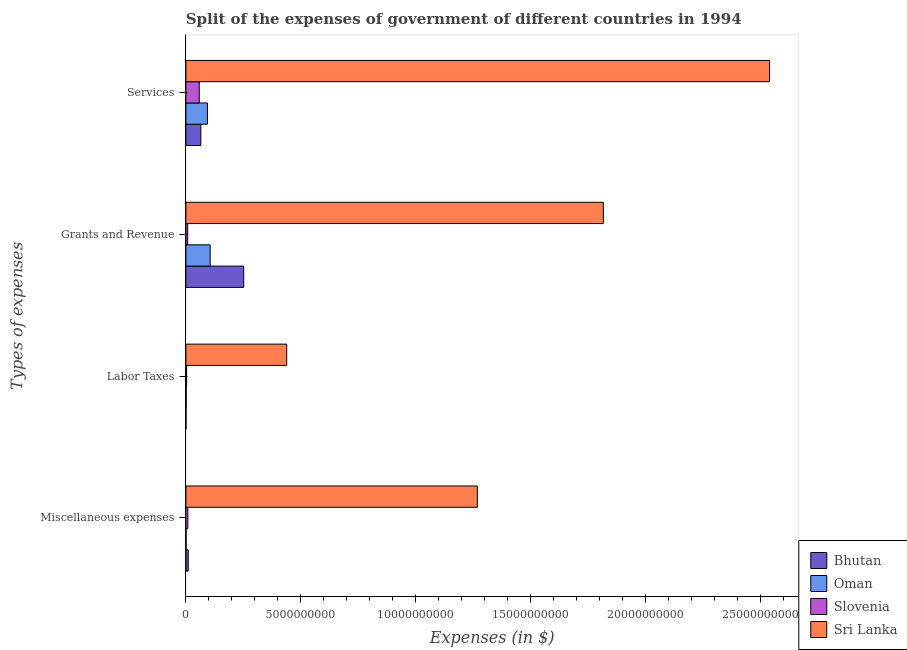How many different coloured bars are there?
Give a very brief answer. 4. Are the number of bars on each tick of the Y-axis equal?
Offer a very short reply. Yes. How many bars are there on the 4th tick from the top?
Make the answer very short. 4. How many bars are there on the 1st tick from the bottom?
Your answer should be compact. 4. What is the label of the 1st group of bars from the top?
Ensure brevity in your answer.  Services. What is the amount spent on services in Slovenia?
Your answer should be compact. 5.81e+08. Across all countries, what is the maximum amount spent on services?
Your answer should be compact. 2.54e+1. Across all countries, what is the minimum amount spent on labor taxes?
Offer a terse response. 6.70e+06. In which country was the amount spent on miscellaneous expenses maximum?
Your response must be concise. Sri Lanka. In which country was the amount spent on services minimum?
Ensure brevity in your answer.  Slovenia. What is the total amount spent on labor taxes in the graph?
Your answer should be very brief. 4.44e+09. What is the difference between the amount spent on grants and revenue in Sri Lanka and that in Slovenia?
Ensure brevity in your answer.  1.81e+1. What is the difference between the amount spent on miscellaneous expenses in Oman and the amount spent on grants and revenue in Slovenia?
Keep it short and to the point. -6.95e+07. What is the average amount spent on grants and revenue per country?
Ensure brevity in your answer.  5.45e+09. What is the difference between the amount spent on grants and revenue and amount spent on labor taxes in Bhutan?
Your answer should be very brief. 2.51e+09. In how many countries, is the amount spent on grants and revenue greater than 1000000000 $?
Offer a very short reply. 3. What is the ratio of the amount spent on miscellaneous expenses in Sri Lanka to that in Oman?
Make the answer very short. 1491.65. What is the difference between the highest and the second highest amount spent on miscellaneous expenses?
Ensure brevity in your answer.  1.26e+1. What is the difference between the highest and the lowest amount spent on services?
Your answer should be very brief. 2.48e+1. In how many countries, is the amount spent on miscellaneous expenses greater than the average amount spent on miscellaneous expenses taken over all countries?
Offer a very short reply. 1. Is the sum of the amount spent on services in Slovenia and Bhutan greater than the maximum amount spent on labor taxes across all countries?
Give a very brief answer. No. Is it the case that in every country, the sum of the amount spent on labor taxes and amount spent on miscellaneous expenses is greater than the sum of amount spent on services and amount spent on grants and revenue?
Keep it short and to the point. No. What does the 2nd bar from the top in Grants and Revenue represents?
Provide a short and direct response. Slovenia. What does the 2nd bar from the bottom in Grants and Revenue represents?
Ensure brevity in your answer.  Oman. What is the difference between two consecutive major ticks on the X-axis?
Your answer should be very brief. 5.00e+09. Does the graph contain grids?
Give a very brief answer. No. What is the title of the graph?
Provide a succinct answer. Split of the expenses of government of different countries in 1994. Does "Lao PDR" appear as one of the legend labels in the graph?
Make the answer very short. No. What is the label or title of the X-axis?
Provide a short and direct response. Expenses (in $). What is the label or title of the Y-axis?
Give a very brief answer. Types of expenses. What is the Expenses (in $) in Bhutan in Miscellaneous expenses?
Give a very brief answer. 1.03e+08. What is the Expenses (in $) of Oman in Miscellaneous expenses?
Give a very brief answer. 8.50e+06. What is the Expenses (in $) of Slovenia in Miscellaneous expenses?
Give a very brief answer. 8.64e+07. What is the Expenses (in $) of Sri Lanka in Miscellaneous expenses?
Offer a very short reply. 1.27e+1. What is the Expenses (in $) in Bhutan in Labor Taxes?
Keep it short and to the point. 6.70e+06. What is the Expenses (in $) in Oman in Labor Taxes?
Offer a terse response. 1.62e+07. What is the Expenses (in $) of Slovenia in Labor Taxes?
Keep it short and to the point. 3.09e+07. What is the Expenses (in $) in Sri Lanka in Labor Taxes?
Make the answer very short. 4.39e+09. What is the Expenses (in $) in Bhutan in Grants and Revenue?
Provide a succinct answer. 2.52e+09. What is the Expenses (in $) of Oman in Grants and Revenue?
Provide a short and direct response. 1.06e+09. What is the Expenses (in $) of Slovenia in Grants and Revenue?
Offer a very short reply. 7.80e+07. What is the Expenses (in $) of Sri Lanka in Grants and Revenue?
Keep it short and to the point. 1.82e+1. What is the Expenses (in $) of Bhutan in Services?
Provide a succinct answer. 6.51e+08. What is the Expenses (in $) of Oman in Services?
Your answer should be very brief. 9.37e+08. What is the Expenses (in $) in Slovenia in Services?
Make the answer very short. 5.81e+08. What is the Expenses (in $) of Sri Lanka in Services?
Offer a terse response. 2.54e+1. Across all Types of expenses, what is the maximum Expenses (in $) in Bhutan?
Keep it short and to the point. 2.52e+09. Across all Types of expenses, what is the maximum Expenses (in $) of Oman?
Keep it short and to the point. 1.06e+09. Across all Types of expenses, what is the maximum Expenses (in $) of Slovenia?
Offer a terse response. 5.81e+08. Across all Types of expenses, what is the maximum Expenses (in $) in Sri Lanka?
Offer a very short reply. 2.54e+1. Across all Types of expenses, what is the minimum Expenses (in $) in Bhutan?
Your response must be concise. 6.70e+06. Across all Types of expenses, what is the minimum Expenses (in $) in Oman?
Keep it short and to the point. 8.50e+06. Across all Types of expenses, what is the minimum Expenses (in $) in Slovenia?
Provide a succinct answer. 3.09e+07. Across all Types of expenses, what is the minimum Expenses (in $) of Sri Lanka?
Ensure brevity in your answer.  4.39e+09. What is the total Expenses (in $) of Bhutan in the graph?
Provide a succinct answer. 3.28e+09. What is the total Expenses (in $) in Oman in the graph?
Provide a short and direct response. 2.02e+09. What is the total Expenses (in $) in Slovenia in the graph?
Make the answer very short. 7.76e+08. What is the total Expenses (in $) of Sri Lanka in the graph?
Give a very brief answer. 6.06e+1. What is the difference between the Expenses (in $) in Bhutan in Miscellaneous expenses and that in Labor Taxes?
Make the answer very short. 9.59e+07. What is the difference between the Expenses (in $) in Oman in Miscellaneous expenses and that in Labor Taxes?
Provide a succinct answer. -7.70e+06. What is the difference between the Expenses (in $) of Slovenia in Miscellaneous expenses and that in Labor Taxes?
Provide a succinct answer. 5.55e+07. What is the difference between the Expenses (in $) in Sri Lanka in Miscellaneous expenses and that in Labor Taxes?
Your answer should be very brief. 8.29e+09. What is the difference between the Expenses (in $) of Bhutan in Miscellaneous expenses and that in Grants and Revenue?
Make the answer very short. -2.41e+09. What is the difference between the Expenses (in $) in Oman in Miscellaneous expenses and that in Grants and Revenue?
Give a very brief answer. -1.05e+09. What is the difference between the Expenses (in $) of Slovenia in Miscellaneous expenses and that in Grants and Revenue?
Make the answer very short. 8.35e+06. What is the difference between the Expenses (in $) in Sri Lanka in Miscellaneous expenses and that in Grants and Revenue?
Offer a very short reply. -5.48e+09. What is the difference between the Expenses (in $) of Bhutan in Miscellaneous expenses and that in Services?
Ensure brevity in your answer.  -5.48e+08. What is the difference between the Expenses (in $) of Oman in Miscellaneous expenses and that in Services?
Ensure brevity in your answer.  -9.29e+08. What is the difference between the Expenses (in $) in Slovenia in Miscellaneous expenses and that in Services?
Your answer should be very brief. -4.94e+08. What is the difference between the Expenses (in $) in Sri Lanka in Miscellaneous expenses and that in Services?
Ensure brevity in your answer.  -1.27e+1. What is the difference between the Expenses (in $) of Bhutan in Labor Taxes and that in Grants and Revenue?
Offer a very short reply. -2.51e+09. What is the difference between the Expenses (in $) in Oman in Labor Taxes and that in Grants and Revenue?
Your answer should be compact. -1.04e+09. What is the difference between the Expenses (in $) of Slovenia in Labor Taxes and that in Grants and Revenue?
Your answer should be compact. -4.72e+07. What is the difference between the Expenses (in $) in Sri Lanka in Labor Taxes and that in Grants and Revenue?
Offer a very short reply. -1.38e+1. What is the difference between the Expenses (in $) in Bhutan in Labor Taxes and that in Services?
Provide a short and direct response. -6.44e+08. What is the difference between the Expenses (in $) of Oman in Labor Taxes and that in Services?
Your response must be concise. -9.21e+08. What is the difference between the Expenses (in $) of Slovenia in Labor Taxes and that in Services?
Give a very brief answer. -5.50e+08. What is the difference between the Expenses (in $) in Sri Lanka in Labor Taxes and that in Services?
Give a very brief answer. -2.10e+1. What is the difference between the Expenses (in $) in Bhutan in Grants and Revenue and that in Services?
Provide a short and direct response. 1.86e+09. What is the difference between the Expenses (in $) of Oman in Grants and Revenue and that in Services?
Make the answer very short. 1.19e+08. What is the difference between the Expenses (in $) of Slovenia in Grants and Revenue and that in Services?
Provide a short and direct response. -5.03e+08. What is the difference between the Expenses (in $) of Sri Lanka in Grants and Revenue and that in Services?
Your answer should be very brief. -7.23e+09. What is the difference between the Expenses (in $) in Bhutan in Miscellaneous expenses and the Expenses (in $) in Oman in Labor Taxes?
Your answer should be very brief. 8.64e+07. What is the difference between the Expenses (in $) in Bhutan in Miscellaneous expenses and the Expenses (in $) in Slovenia in Labor Taxes?
Your answer should be very brief. 7.17e+07. What is the difference between the Expenses (in $) of Bhutan in Miscellaneous expenses and the Expenses (in $) of Sri Lanka in Labor Taxes?
Your answer should be very brief. -4.28e+09. What is the difference between the Expenses (in $) of Oman in Miscellaneous expenses and the Expenses (in $) of Slovenia in Labor Taxes?
Your answer should be very brief. -2.24e+07. What is the difference between the Expenses (in $) in Oman in Miscellaneous expenses and the Expenses (in $) in Sri Lanka in Labor Taxes?
Offer a terse response. -4.38e+09. What is the difference between the Expenses (in $) in Slovenia in Miscellaneous expenses and the Expenses (in $) in Sri Lanka in Labor Taxes?
Give a very brief answer. -4.30e+09. What is the difference between the Expenses (in $) in Bhutan in Miscellaneous expenses and the Expenses (in $) in Oman in Grants and Revenue?
Keep it short and to the point. -9.54e+08. What is the difference between the Expenses (in $) of Bhutan in Miscellaneous expenses and the Expenses (in $) of Slovenia in Grants and Revenue?
Ensure brevity in your answer.  2.46e+07. What is the difference between the Expenses (in $) in Bhutan in Miscellaneous expenses and the Expenses (in $) in Sri Lanka in Grants and Revenue?
Offer a very short reply. -1.81e+1. What is the difference between the Expenses (in $) in Oman in Miscellaneous expenses and the Expenses (in $) in Slovenia in Grants and Revenue?
Keep it short and to the point. -6.95e+07. What is the difference between the Expenses (in $) of Oman in Miscellaneous expenses and the Expenses (in $) of Sri Lanka in Grants and Revenue?
Provide a short and direct response. -1.82e+1. What is the difference between the Expenses (in $) in Slovenia in Miscellaneous expenses and the Expenses (in $) in Sri Lanka in Grants and Revenue?
Provide a succinct answer. -1.81e+1. What is the difference between the Expenses (in $) of Bhutan in Miscellaneous expenses and the Expenses (in $) of Oman in Services?
Make the answer very short. -8.35e+08. What is the difference between the Expenses (in $) of Bhutan in Miscellaneous expenses and the Expenses (in $) of Slovenia in Services?
Your response must be concise. -4.78e+08. What is the difference between the Expenses (in $) of Bhutan in Miscellaneous expenses and the Expenses (in $) of Sri Lanka in Services?
Your answer should be very brief. -2.53e+1. What is the difference between the Expenses (in $) of Oman in Miscellaneous expenses and the Expenses (in $) of Slovenia in Services?
Make the answer very short. -5.72e+08. What is the difference between the Expenses (in $) in Oman in Miscellaneous expenses and the Expenses (in $) in Sri Lanka in Services?
Your response must be concise. -2.54e+1. What is the difference between the Expenses (in $) in Slovenia in Miscellaneous expenses and the Expenses (in $) in Sri Lanka in Services?
Keep it short and to the point. -2.53e+1. What is the difference between the Expenses (in $) of Bhutan in Labor Taxes and the Expenses (in $) of Oman in Grants and Revenue?
Provide a succinct answer. -1.05e+09. What is the difference between the Expenses (in $) in Bhutan in Labor Taxes and the Expenses (in $) in Slovenia in Grants and Revenue?
Give a very brief answer. -7.13e+07. What is the difference between the Expenses (in $) of Bhutan in Labor Taxes and the Expenses (in $) of Sri Lanka in Grants and Revenue?
Your response must be concise. -1.82e+1. What is the difference between the Expenses (in $) of Oman in Labor Taxes and the Expenses (in $) of Slovenia in Grants and Revenue?
Your answer should be very brief. -6.18e+07. What is the difference between the Expenses (in $) of Oman in Labor Taxes and the Expenses (in $) of Sri Lanka in Grants and Revenue?
Ensure brevity in your answer.  -1.81e+1. What is the difference between the Expenses (in $) of Slovenia in Labor Taxes and the Expenses (in $) of Sri Lanka in Grants and Revenue?
Your answer should be compact. -1.81e+1. What is the difference between the Expenses (in $) in Bhutan in Labor Taxes and the Expenses (in $) in Oman in Services?
Ensure brevity in your answer.  -9.31e+08. What is the difference between the Expenses (in $) of Bhutan in Labor Taxes and the Expenses (in $) of Slovenia in Services?
Provide a succinct answer. -5.74e+08. What is the difference between the Expenses (in $) in Bhutan in Labor Taxes and the Expenses (in $) in Sri Lanka in Services?
Provide a succinct answer. -2.54e+1. What is the difference between the Expenses (in $) in Oman in Labor Taxes and the Expenses (in $) in Slovenia in Services?
Make the answer very short. -5.65e+08. What is the difference between the Expenses (in $) of Oman in Labor Taxes and the Expenses (in $) of Sri Lanka in Services?
Your response must be concise. -2.54e+1. What is the difference between the Expenses (in $) in Slovenia in Labor Taxes and the Expenses (in $) in Sri Lanka in Services?
Your response must be concise. -2.54e+1. What is the difference between the Expenses (in $) in Bhutan in Grants and Revenue and the Expenses (in $) in Oman in Services?
Ensure brevity in your answer.  1.58e+09. What is the difference between the Expenses (in $) in Bhutan in Grants and Revenue and the Expenses (in $) in Slovenia in Services?
Your response must be concise. 1.93e+09. What is the difference between the Expenses (in $) in Bhutan in Grants and Revenue and the Expenses (in $) in Sri Lanka in Services?
Give a very brief answer. -2.29e+1. What is the difference between the Expenses (in $) in Oman in Grants and Revenue and the Expenses (in $) in Slovenia in Services?
Offer a very short reply. 4.75e+08. What is the difference between the Expenses (in $) of Oman in Grants and Revenue and the Expenses (in $) of Sri Lanka in Services?
Give a very brief answer. -2.43e+1. What is the difference between the Expenses (in $) of Slovenia in Grants and Revenue and the Expenses (in $) of Sri Lanka in Services?
Make the answer very short. -2.53e+1. What is the average Expenses (in $) in Bhutan per Types of expenses?
Provide a short and direct response. 8.19e+08. What is the average Expenses (in $) in Oman per Types of expenses?
Provide a short and direct response. 5.05e+08. What is the average Expenses (in $) in Slovenia per Types of expenses?
Provide a succinct answer. 1.94e+08. What is the average Expenses (in $) in Sri Lanka per Types of expenses?
Your response must be concise. 1.52e+1. What is the difference between the Expenses (in $) in Bhutan and Expenses (in $) in Oman in Miscellaneous expenses?
Your answer should be compact. 9.41e+07. What is the difference between the Expenses (in $) in Bhutan and Expenses (in $) in Slovenia in Miscellaneous expenses?
Offer a very short reply. 1.62e+07. What is the difference between the Expenses (in $) in Bhutan and Expenses (in $) in Sri Lanka in Miscellaneous expenses?
Keep it short and to the point. -1.26e+1. What is the difference between the Expenses (in $) of Oman and Expenses (in $) of Slovenia in Miscellaneous expenses?
Your answer should be compact. -7.79e+07. What is the difference between the Expenses (in $) in Oman and Expenses (in $) in Sri Lanka in Miscellaneous expenses?
Offer a terse response. -1.27e+1. What is the difference between the Expenses (in $) of Slovenia and Expenses (in $) of Sri Lanka in Miscellaneous expenses?
Your response must be concise. -1.26e+1. What is the difference between the Expenses (in $) in Bhutan and Expenses (in $) in Oman in Labor Taxes?
Provide a short and direct response. -9.50e+06. What is the difference between the Expenses (in $) of Bhutan and Expenses (in $) of Slovenia in Labor Taxes?
Your answer should be compact. -2.42e+07. What is the difference between the Expenses (in $) of Bhutan and Expenses (in $) of Sri Lanka in Labor Taxes?
Provide a short and direct response. -4.38e+09. What is the difference between the Expenses (in $) in Oman and Expenses (in $) in Slovenia in Labor Taxes?
Your answer should be compact. -1.47e+07. What is the difference between the Expenses (in $) in Oman and Expenses (in $) in Sri Lanka in Labor Taxes?
Keep it short and to the point. -4.37e+09. What is the difference between the Expenses (in $) in Slovenia and Expenses (in $) in Sri Lanka in Labor Taxes?
Give a very brief answer. -4.36e+09. What is the difference between the Expenses (in $) of Bhutan and Expenses (in $) of Oman in Grants and Revenue?
Make the answer very short. 1.46e+09. What is the difference between the Expenses (in $) of Bhutan and Expenses (in $) of Slovenia in Grants and Revenue?
Your answer should be very brief. 2.44e+09. What is the difference between the Expenses (in $) of Bhutan and Expenses (in $) of Sri Lanka in Grants and Revenue?
Your answer should be compact. -1.56e+1. What is the difference between the Expenses (in $) in Oman and Expenses (in $) in Slovenia in Grants and Revenue?
Your response must be concise. 9.78e+08. What is the difference between the Expenses (in $) in Oman and Expenses (in $) in Sri Lanka in Grants and Revenue?
Give a very brief answer. -1.71e+1. What is the difference between the Expenses (in $) of Slovenia and Expenses (in $) of Sri Lanka in Grants and Revenue?
Offer a terse response. -1.81e+1. What is the difference between the Expenses (in $) in Bhutan and Expenses (in $) in Oman in Services?
Your answer should be very brief. -2.87e+08. What is the difference between the Expenses (in $) of Bhutan and Expenses (in $) of Slovenia in Services?
Your answer should be compact. 6.97e+07. What is the difference between the Expenses (in $) in Bhutan and Expenses (in $) in Sri Lanka in Services?
Your response must be concise. -2.47e+1. What is the difference between the Expenses (in $) in Oman and Expenses (in $) in Slovenia in Services?
Your answer should be compact. 3.57e+08. What is the difference between the Expenses (in $) in Oman and Expenses (in $) in Sri Lanka in Services?
Your answer should be very brief. -2.45e+1. What is the difference between the Expenses (in $) of Slovenia and Expenses (in $) of Sri Lanka in Services?
Provide a short and direct response. -2.48e+1. What is the ratio of the Expenses (in $) of Bhutan in Miscellaneous expenses to that in Labor Taxes?
Give a very brief answer. 15.31. What is the ratio of the Expenses (in $) in Oman in Miscellaneous expenses to that in Labor Taxes?
Make the answer very short. 0.52. What is the ratio of the Expenses (in $) of Slovenia in Miscellaneous expenses to that in Labor Taxes?
Provide a short and direct response. 2.8. What is the ratio of the Expenses (in $) in Sri Lanka in Miscellaneous expenses to that in Labor Taxes?
Ensure brevity in your answer.  2.89. What is the ratio of the Expenses (in $) of Bhutan in Miscellaneous expenses to that in Grants and Revenue?
Your answer should be very brief. 0.04. What is the ratio of the Expenses (in $) in Oman in Miscellaneous expenses to that in Grants and Revenue?
Keep it short and to the point. 0.01. What is the ratio of the Expenses (in $) of Slovenia in Miscellaneous expenses to that in Grants and Revenue?
Make the answer very short. 1.11. What is the ratio of the Expenses (in $) in Sri Lanka in Miscellaneous expenses to that in Grants and Revenue?
Offer a very short reply. 0.7. What is the ratio of the Expenses (in $) of Bhutan in Miscellaneous expenses to that in Services?
Provide a succinct answer. 0.16. What is the ratio of the Expenses (in $) of Oman in Miscellaneous expenses to that in Services?
Ensure brevity in your answer.  0.01. What is the ratio of the Expenses (in $) in Slovenia in Miscellaneous expenses to that in Services?
Ensure brevity in your answer.  0.15. What is the ratio of the Expenses (in $) of Sri Lanka in Miscellaneous expenses to that in Services?
Your answer should be very brief. 0.5. What is the ratio of the Expenses (in $) of Bhutan in Labor Taxes to that in Grants and Revenue?
Make the answer very short. 0. What is the ratio of the Expenses (in $) of Oman in Labor Taxes to that in Grants and Revenue?
Keep it short and to the point. 0.02. What is the ratio of the Expenses (in $) of Slovenia in Labor Taxes to that in Grants and Revenue?
Your answer should be very brief. 0.4. What is the ratio of the Expenses (in $) of Sri Lanka in Labor Taxes to that in Grants and Revenue?
Make the answer very short. 0.24. What is the ratio of the Expenses (in $) in Bhutan in Labor Taxes to that in Services?
Offer a very short reply. 0.01. What is the ratio of the Expenses (in $) in Oman in Labor Taxes to that in Services?
Provide a succinct answer. 0.02. What is the ratio of the Expenses (in $) in Slovenia in Labor Taxes to that in Services?
Your answer should be compact. 0.05. What is the ratio of the Expenses (in $) of Sri Lanka in Labor Taxes to that in Services?
Offer a terse response. 0.17. What is the ratio of the Expenses (in $) of Bhutan in Grants and Revenue to that in Services?
Provide a short and direct response. 3.87. What is the ratio of the Expenses (in $) in Oman in Grants and Revenue to that in Services?
Offer a very short reply. 1.13. What is the ratio of the Expenses (in $) in Slovenia in Grants and Revenue to that in Services?
Give a very brief answer. 0.13. What is the ratio of the Expenses (in $) in Sri Lanka in Grants and Revenue to that in Services?
Give a very brief answer. 0.72. What is the difference between the highest and the second highest Expenses (in $) in Bhutan?
Your response must be concise. 1.86e+09. What is the difference between the highest and the second highest Expenses (in $) in Oman?
Make the answer very short. 1.19e+08. What is the difference between the highest and the second highest Expenses (in $) of Slovenia?
Your response must be concise. 4.94e+08. What is the difference between the highest and the second highest Expenses (in $) of Sri Lanka?
Offer a terse response. 7.23e+09. What is the difference between the highest and the lowest Expenses (in $) of Bhutan?
Provide a short and direct response. 2.51e+09. What is the difference between the highest and the lowest Expenses (in $) of Oman?
Provide a short and direct response. 1.05e+09. What is the difference between the highest and the lowest Expenses (in $) in Slovenia?
Your answer should be compact. 5.50e+08. What is the difference between the highest and the lowest Expenses (in $) of Sri Lanka?
Your response must be concise. 2.10e+1. 